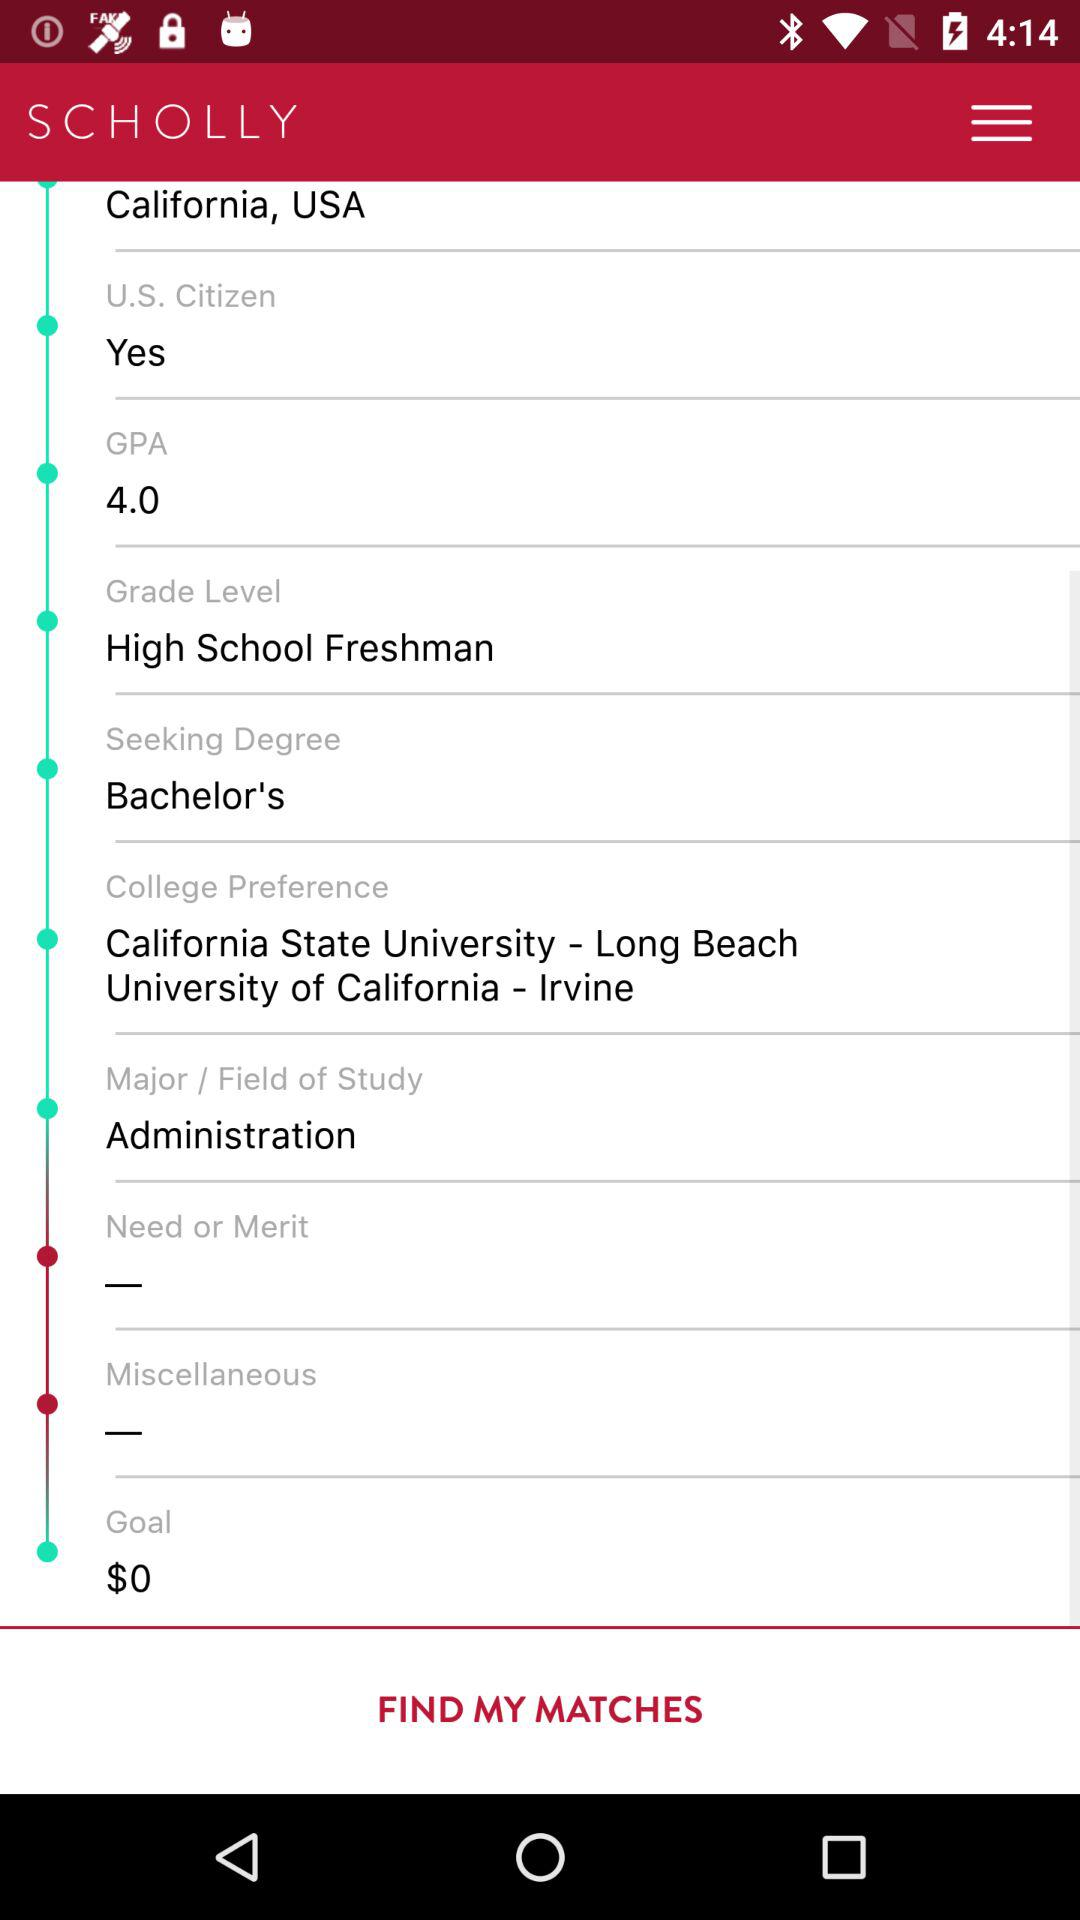What is the status of "U.S. Citizen"? The status is "Yes". 